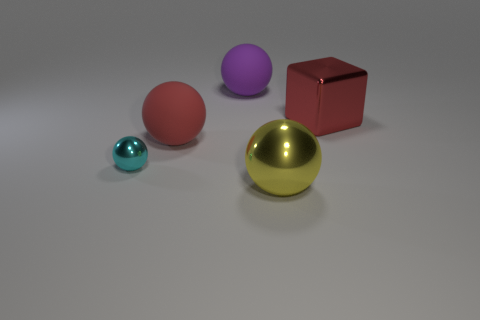What number of other objects are the same size as the cyan shiny thing?
Your answer should be compact. 0. There is a metal sphere that is on the left side of the yellow thing; what size is it?
Ensure brevity in your answer.  Small. What number of large brown objects are made of the same material as the tiny cyan thing?
Make the answer very short. 0. Do the large red thing right of the yellow shiny thing and the cyan object have the same shape?
Provide a succinct answer. No. What shape is the large shiny object in front of the red metallic object?
Your response must be concise. Sphere. What is the material of the yellow ball?
Your response must be concise. Metal. What color is the metallic block that is the same size as the yellow sphere?
Ensure brevity in your answer.  Red. What shape is the thing that is the same color as the large shiny cube?
Your answer should be very brief. Sphere. Is the shape of the large purple rubber thing the same as the small object?
Provide a succinct answer. Yes. There is a thing that is in front of the red rubber sphere and on the left side of the large yellow metallic sphere; what is it made of?
Offer a terse response. Metal. 